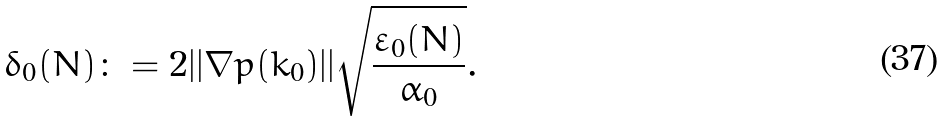Convert formula to latex. <formula><loc_0><loc_0><loc_500><loc_500>\delta _ { 0 } ( N ) \colon = 2 | | \nabla p ( k _ { 0 } ) | | \sqrt { \frac { \varepsilon _ { 0 } ( N ) } { \alpha _ { 0 } } } .</formula> 